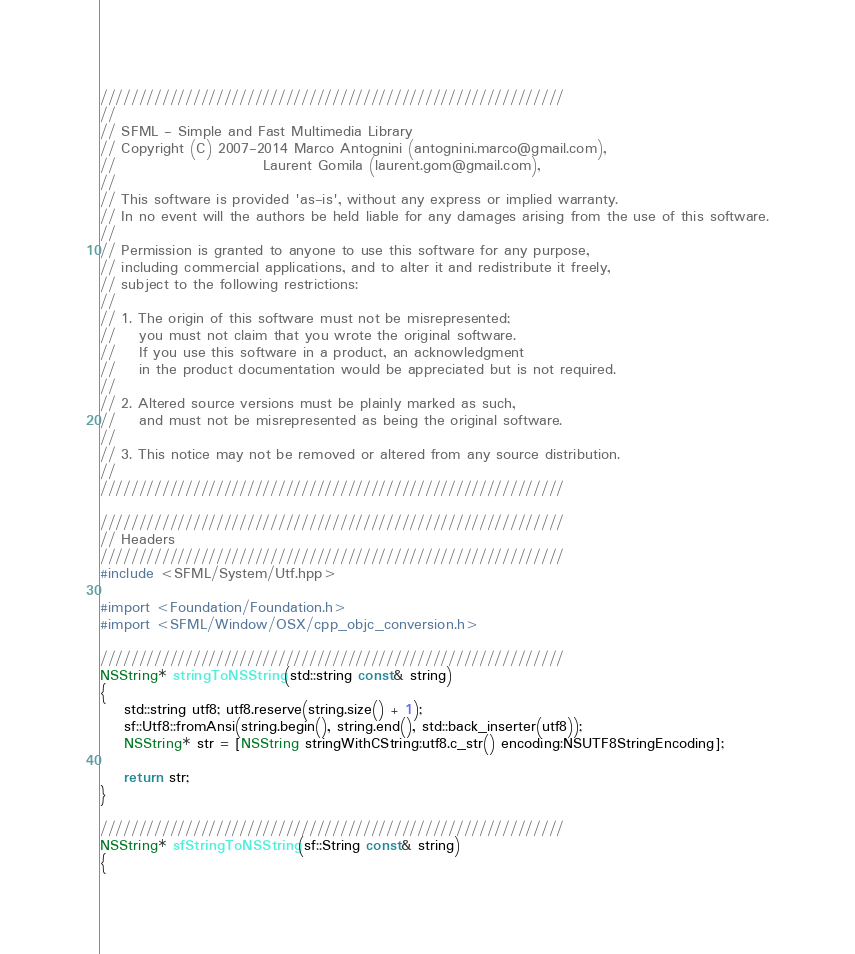<code> <loc_0><loc_0><loc_500><loc_500><_ObjectiveC_>////////////////////////////////////////////////////////////
//
// SFML - Simple and Fast Multimedia Library
// Copyright (C) 2007-2014 Marco Antognini (antognini.marco@gmail.com),
//                         Laurent Gomila (laurent.gom@gmail.com),
//
// This software is provided 'as-is', without any express or implied warranty.
// In no event will the authors be held liable for any damages arising from the use of this software.
//
// Permission is granted to anyone to use this software for any purpose,
// including commercial applications, and to alter it and redistribute it freely,
// subject to the following restrictions:
//
// 1. The origin of this software must not be misrepresented;
//    you must not claim that you wrote the original software.
//    If you use this software in a product, an acknowledgment
//    in the product documentation would be appreciated but is not required.
//
// 2. Altered source versions must be plainly marked as such,
//    and must not be misrepresented as being the original software.
//
// 3. This notice may not be removed or altered from any source distribution.
//
////////////////////////////////////////////////////////////

////////////////////////////////////////////////////////////
// Headers
////////////////////////////////////////////////////////////
#include <SFML/System/Utf.hpp>

#import <Foundation/Foundation.h>
#import <SFML/Window/OSX/cpp_objc_conversion.h>

////////////////////////////////////////////////////////////
NSString* stringToNSString(std::string const& string)
{
    std::string utf8; utf8.reserve(string.size() + 1);
    sf::Utf8::fromAnsi(string.begin(), string.end(), std::back_inserter(utf8));
    NSString* str = [NSString stringWithCString:utf8.c_str() encoding:NSUTF8StringEncoding];

    return str;
}

////////////////////////////////////////////////////////////
NSString* sfStringToNSString(sf::String const& string)
{</code> 